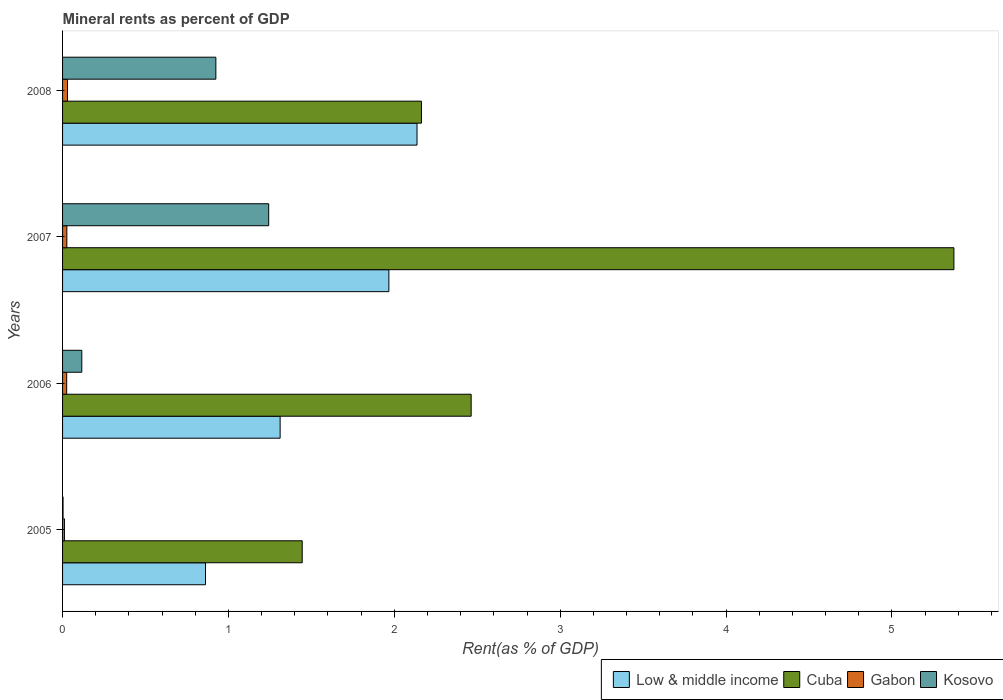How many groups of bars are there?
Make the answer very short. 4. How many bars are there on the 2nd tick from the top?
Your response must be concise. 4. How many bars are there on the 4th tick from the bottom?
Your answer should be very brief. 4. What is the label of the 4th group of bars from the top?
Ensure brevity in your answer.  2005. What is the mineral rent in Gabon in 2006?
Ensure brevity in your answer.  0.02. Across all years, what is the maximum mineral rent in Low & middle income?
Your response must be concise. 2.14. Across all years, what is the minimum mineral rent in Kosovo?
Your answer should be very brief. 0. What is the total mineral rent in Gabon in the graph?
Offer a terse response. 0.09. What is the difference between the mineral rent in Low & middle income in 2006 and that in 2008?
Give a very brief answer. -0.83. What is the difference between the mineral rent in Low & middle income in 2006 and the mineral rent in Cuba in 2008?
Your answer should be compact. -0.85. What is the average mineral rent in Kosovo per year?
Offer a terse response. 0.57. In the year 2006, what is the difference between the mineral rent in Low & middle income and mineral rent in Cuba?
Give a very brief answer. -1.15. What is the ratio of the mineral rent in Kosovo in 2006 to that in 2007?
Your answer should be very brief. 0.09. Is the mineral rent in Cuba in 2005 less than that in 2008?
Provide a succinct answer. Yes. What is the difference between the highest and the second highest mineral rent in Kosovo?
Your answer should be compact. 0.32. What is the difference between the highest and the lowest mineral rent in Kosovo?
Keep it short and to the point. 1.24. In how many years, is the mineral rent in Cuba greater than the average mineral rent in Cuba taken over all years?
Offer a terse response. 1. Is it the case that in every year, the sum of the mineral rent in Cuba and mineral rent in Low & middle income is greater than the sum of mineral rent in Gabon and mineral rent in Kosovo?
Make the answer very short. No. What does the 1st bar from the top in 2005 represents?
Your answer should be very brief. Kosovo. What does the 1st bar from the bottom in 2006 represents?
Provide a short and direct response. Low & middle income. Are all the bars in the graph horizontal?
Ensure brevity in your answer.  Yes. What is the difference between two consecutive major ticks on the X-axis?
Ensure brevity in your answer.  1. Are the values on the major ticks of X-axis written in scientific E-notation?
Give a very brief answer. No. Does the graph contain any zero values?
Keep it short and to the point. No. Does the graph contain grids?
Make the answer very short. No. Where does the legend appear in the graph?
Make the answer very short. Bottom right. How many legend labels are there?
Keep it short and to the point. 4. What is the title of the graph?
Your response must be concise. Mineral rents as percent of GDP. Does "Portugal" appear as one of the legend labels in the graph?
Provide a short and direct response. No. What is the label or title of the X-axis?
Ensure brevity in your answer.  Rent(as % of GDP). What is the Rent(as % of GDP) of Low & middle income in 2005?
Your answer should be very brief. 0.86. What is the Rent(as % of GDP) of Cuba in 2005?
Ensure brevity in your answer.  1.44. What is the Rent(as % of GDP) of Gabon in 2005?
Provide a succinct answer. 0.01. What is the Rent(as % of GDP) of Kosovo in 2005?
Make the answer very short. 0. What is the Rent(as % of GDP) of Low & middle income in 2006?
Make the answer very short. 1.31. What is the Rent(as % of GDP) in Cuba in 2006?
Keep it short and to the point. 2.46. What is the Rent(as % of GDP) in Gabon in 2006?
Provide a succinct answer. 0.02. What is the Rent(as % of GDP) of Kosovo in 2006?
Give a very brief answer. 0.12. What is the Rent(as % of GDP) in Low & middle income in 2007?
Offer a very short reply. 1.97. What is the Rent(as % of GDP) of Cuba in 2007?
Provide a short and direct response. 5.37. What is the Rent(as % of GDP) in Gabon in 2007?
Ensure brevity in your answer.  0.03. What is the Rent(as % of GDP) of Kosovo in 2007?
Offer a terse response. 1.24. What is the Rent(as % of GDP) in Low & middle income in 2008?
Offer a terse response. 2.14. What is the Rent(as % of GDP) in Cuba in 2008?
Ensure brevity in your answer.  2.16. What is the Rent(as % of GDP) in Gabon in 2008?
Ensure brevity in your answer.  0.03. What is the Rent(as % of GDP) of Kosovo in 2008?
Offer a terse response. 0.92. Across all years, what is the maximum Rent(as % of GDP) of Low & middle income?
Keep it short and to the point. 2.14. Across all years, what is the maximum Rent(as % of GDP) in Cuba?
Your answer should be compact. 5.37. Across all years, what is the maximum Rent(as % of GDP) of Gabon?
Offer a terse response. 0.03. Across all years, what is the maximum Rent(as % of GDP) of Kosovo?
Keep it short and to the point. 1.24. Across all years, what is the minimum Rent(as % of GDP) in Low & middle income?
Make the answer very short. 0.86. Across all years, what is the minimum Rent(as % of GDP) in Cuba?
Provide a succinct answer. 1.44. Across all years, what is the minimum Rent(as % of GDP) in Gabon?
Your answer should be compact. 0.01. Across all years, what is the minimum Rent(as % of GDP) of Kosovo?
Provide a succinct answer. 0. What is the total Rent(as % of GDP) of Low & middle income in the graph?
Offer a very short reply. 6.28. What is the total Rent(as % of GDP) in Cuba in the graph?
Provide a succinct answer. 11.44. What is the total Rent(as % of GDP) of Gabon in the graph?
Provide a succinct answer. 0.09. What is the total Rent(as % of GDP) of Kosovo in the graph?
Your response must be concise. 2.29. What is the difference between the Rent(as % of GDP) in Low & middle income in 2005 and that in 2006?
Offer a terse response. -0.45. What is the difference between the Rent(as % of GDP) in Cuba in 2005 and that in 2006?
Ensure brevity in your answer.  -1.02. What is the difference between the Rent(as % of GDP) of Gabon in 2005 and that in 2006?
Keep it short and to the point. -0.01. What is the difference between the Rent(as % of GDP) in Kosovo in 2005 and that in 2006?
Your answer should be compact. -0.11. What is the difference between the Rent(as % of GDP) of Low & middle income in 2005 and that in 2007?
Offer a very short reply. -1.11. What is the difference between the Rent(as % of GDP) in Cuba in 2005 and that in 2007?
Ensure brevity in your answer.  -3.93. What is the difference between the Rent(as % of GDP) in Gabon in 2005 and that in 2007?
Offer a very short reply. -0.01. What is the difference between the Rent(as % of GDP) of Kosovo in 2005 and that in 2007?
Ensure brevity in your answer.  -1.24. What is the difference between the Rent(as % of GDP) of Low & middle income in 2005 and that in 2008?
Your response must be concise. -1.28. What is the difference between the Rent(as % of GDP) of Cuba in 2005 and that in 2008?
Give a very brief answer. -0.72. What is the difference between the Rent(as % of GDP) of Gabon in 2005 and that in 2008?
Your answer should be compact. -0.02. What is the difference between the Rent(as % of GDP) of Kosovo in 2005 and that in 2008?
Provide a short and direct response. -0.92. What is the difference between the Rent(as % of GDP) of Low & middle income in 2006 and that in 2007?
Provide a short and direct response. -0.66. What is the difference between the Rent(as % of GDP) of Cuba in 2006 and that in 2007?
Provide a short and direct response. -2.91. What is the difference between the Rent(as % of GDP) of Gabon in 2006 and that in 2007?
Ensure brevity in your answer.  -0. What is the difference between the Rent(as % of GDP) of Kosovo in 2006 and that in 2007?
Offer a terse response. -1.13. What is the difference between the Rent(as % of GDP) of Low & middle income in 2006 and that in 2008?
Provide a succinct answer. -0.83. What is the difference between the Rent(as % of GDP) in Cuba in 2006 and that in 2008?
Offer a terse response. 0.3. What is the difference between the Rent(as % of GDP) in Gabon in 2006 and that in 2008?
Your response must be concise. -0.01. What is the difference between the Rent(as % of GDP) in Kosovo in 2006 and that in 2008?
Ensure brevity in your answer.  -0.81. What is the difference between the Rent(as % of GDP) of Low & middle income in 2007 and that in 2008?
Offer a terse response. -0.17. What is the difference between the Rent(as % of GDP) of Cuba in 2007 and that in 2008?
Ensure brevity in your answer.  3.21. What is the difference between the Rent(as % of GDP) of Gabon in 2007 and that in 2008?
Offer a very short reply. -0. What is the difference between the Rent(as % of GDP) of Kosovo in 2007 and that in 2008?
Your answer should be very brief. 0.32. What is the difference between the Rent(as % of GDP) in Low & middle income in 2005 and the Rent(as % of GDP) in Cuba in 2006?
Keep it short and to the point. -1.6. What is the difference between the Rent(as % of GDP) of Low & middle income in 2005 and the Rent(as % of GDP) of Gabon in 2006?
Ensure brevity in your answer.  0.84. What is the difference between the Rent(as % of GDP) in Low & middle income in 2005 and the Rent(as % of GDP) in Kosovo in 2006?
Provide a short and direct response. 0.75. What is the difference between the Rent(as % of GDP) of Cuba in 2005 and the Rent(as % of GDP) of Gabon in 2006?
Keep it short and to the point. 1.42. What is the difference between the Rent(as % of GDP) of Cuba in 2005 and the Rent(as % of GDP) of Kosovo in 2006?
Give a very brief answer. 1.33. What is the difference between the Rent(as % of GDP) of Gabon in 2005 and the Rent(as % of GDP) of Kosovo in 2006?
Give a very brief answer. -0.1. What is the difference between the Rent(as % of GDP) in Low & middle income in 2005 and the Rent(as % of GDP) in Cuba in 2007?
Offer a very short reply. -4.51. What is the difference between the Rent(as % of GDP) of Low & middle income in 2005 and the Rent(as % of GDP) of Gabon in 2007?
Ensure brevity in your answer.  0.84. What is the difference between the Rent(as % of GDP) in Low & middle income in 2005 and the Rent(as % of GDP) in Kosovo in 2007?
Give a very brief answer. -0.38. What is the difference between the Rent(as % of GDP) of Cuba in 2005 and the Rent(as % of GDP) of Gabon in 2007?
Provide a short and direct response. 1.42. What is the difference between the Rent(as % of GDP) in Cuba in 2005 and the Rent(as % of GDP) in Kosovo in 2007?
Provide a succinct answer. 0.2. What is the difference between the Rent(as % of GDP) in Gabon in 2005 and the Rent(as % of GDP) in Kosovo in 2007?
Keep it short and to the point. -1.23. What is the difference between the Rent(as % of GDP) of Low & middle income in 2005 and the Rent(as % of GDP) of Cuba in 2008?
Keep it short and to the point. -1.3. What is the difference between the Rent(as % of GDP) in Low & middle income in 2005 and the Rent(as % of GDP) in Gabon in 2008?
Offer a terse response. 0.83. What is the difference between the Rent(as % of GDP) in Low & middle income in 2005 and the Rent(as % of GDP) in Kosovo in 2008?
Your answer should be very brief. -0.06. What is the difference between the Rent(as % of GDP) in Cuba in 2005 and the Rent(as % of GDP) in Gabon in 2008?
Your response must be concise. 1.41. What is the difference between the Rent(as % of GDP) of Cuba in 2005 and the Rent(as % of GDP) of Kosovo in 2008?
Ensure brevity in your answer.  0.52. What is the difference between the Rent(as % of GDP) of Gabon in 2005 and the Rent(as % of GDP) of Kosovo in 2008?
Offer a very short reply. -0.91. What is the difference between the Rent(as % of GDP) in Low & middle income in 2006 and the Rent(as % of GDP) in Cuba in 2007?
Offer a terse response. -4.06. What is the difference between the Rent(as % of GDP) of Low & middle income in 2006 and the Rent(as % of GDP) of Kosovo in 2007?
Your answer should be very brief. 0.07. What is the difference between the Rent(as % of GDP) of Cuba in 2006 and the Rent(as % of GDP) of Gabon in 2007?
Ensure brevity in your answer.  2.44. What is the difference between the Rent(as % of GDP) of Cuba in 2006 and the Rent(as % of GDP) of Kosovo in 2007?
Keep it short and to the point. 1.22. What is the difference between the Rent(as % of GDP) of Gabon in 2006 and the Rent(as % of GDP) of Kosovo in 2007?
Your answer should be compact. -1.22. What is the difference between the Rent(as % of GDP) of Low & middle income in 2006 and the Rent(as % of GDP) of Cuba in 2008?
Give a very brief answer. -0.85. What is the difference between the Rent(as % of GDP) of Low & middle income in 2006 and the Rent(as % of GDP) of Gabon in 2008?
Keep it short and to the point. 1.28. What is the difference between the Rent(as % of GDP) of Low & middle income in 2006 and the Rent(as % of GDP) of Kosovo in 2008?
Make the answer very short. 0.39. What is the difference between the Rent(as % of GDP) of Cuba in 2006 and the Rent(as % of GDP) of Gabon in 2008?
Make the answer very short. 2.43. What is the difference between the Rent(as % of GDP) in Cuba in 2006 and the Rent(as % of GDP) in Kosovo in 2008?
Give a very brief answer. 1.54. What is the difference between the Rent(as % of GDP) in Gabon in 2006 and the Rent(as % of GDP) in Kosovo in 2008?
Offer a terse response. -0.9. What is the difference between the Rent(as % of GDP) of Low & middle income in 2007 and the Rent(as % of GDP) of Cuba in 2008?
Provide a short and direct response. -0.2. What is the difference between the Rent(as % of GDP) in Low & middle income in 2007 and the Rent(as % of GDP) in Gabon in 2008?
Your response must be concise. 1.94. What is the difference between the Rent(as % of GDP) of Low & middle income in 2007 and the Rent(as % of GDP) of Kosovo in 2008?
Offer a terse response. 1.04. What is the difference between the Rent(as % of GDP) in Cuba in 2007 and the Rent(as % of GDP) in Gabon in 2008?
Offer a terse response. 5.34. What is the difference between the Rent(as % of GDP) of Cuba in 2007 and the Rent(as % of GDP) of Kosovo in 2008?
Your answer should be very brief. 4.45. What is the difference between the Rent(as % of GDP) of Gabon in 2007 and the Rent(as % of GDP) of Kosovo in 2008?
Provide a short and direct response. -0.9. What is the average Rent(as % of GDP) of Low & middle income per year?
Provide a short and direct response. 1.57. What is the average Rent(as % of GDP) in Cuba per year?
Your answer should be very brief. 2.86. What is the average Rent(as % of GDP) of Gabon per year?
Offer a terse response. 0.02. What is the average Rent(as % of GDP) of Kosovo per year?
Ensure brevity in your answer.  0.57. In the year 2005, what is the difference between the Rent(as % of GDP) of Low & middle income and Rent(as % of GDP) of Cuba?
Ensure brevity in your answer.  -0.58. In the year 2005, what is the difference between the Rent(as % of GDP) of Low & middle income and Rent(as % of GDP) of Gabon?
Make the answer very short. 0.85. In the year 2005, what is the difference between the Rent(as % of GDP) in Low & middle income and Rent(as % of GDP) in Kosovo?
Ensure brevity in your answer.  0.86. In the year 2005, what is the difference between the Rent(as % of GDP) in Cuba and Rent(as % of GDP) in Gabon?
Provide a succinct answer. 1.43. In the year 2005, what is the difference between the Rent(as % of GDP) of Cuba and Rent(as % of GDP) of Kosovo?
Make the answer very short. 1.44. In the year 2005, what is the difference between the Rent(as % of GDP) in Gabon and Rent(as % of GDP) in Kosovo?
Offer a terse response. 0.01. In the year 2006, what is the difference between the Rent(as % of GDP) in Low & middle income and Rent(as % of GDP) in Cuba?
Offer a very short reply. -1.15. In the year 2006, what is the difference between the Rent(as % of GDP) in Low & middle income and Rent(as % of GDP) in Gabon?
Provide a succinct answer. 1.29. In the year 2006, what is the difference between the Rent(as % of GDP) in Low & middle income and Rent(as % of GDP) in Kosovo?
Provide a succinct answer. 1.2. In the year 2006, what is the difference between the Rent(as % of GDP) of Cuba and Rent(as % of GDP) of Gabon?
Provide a succinct answer. 2.44. In the year 2006, what is the difference between the Rent(as % of GDP) of Cuba and Rent(as % of GDP) of Kosovo?
Your response must be concise. 2.35. In the year 2006, what is the difference between the Rent(as % of GDP) in Gabon and Rent(as % of GDP) in Kosovo?
Keep it short and to the point. -0.09. In the year 2007, what is the difference between the Rent(as % of GDP) in Low & middle income and Rent(as % of GDP) in Cuba?
Ensure brevity in your answer.  -3.41. In the year 2007, what is the difference between the Rent(as % of GDP) in Low & middle income and Rent(as % of GDP) in Gabon?
Ensure brevity in your answer.  1.94. In the year 2007, what is the difference between the Rent(as % of GDP) in Low & middle income and Rent(as % of GDP) in Kosovo?
Provide a succinct answer. 0.72. In the year 2007, what is the difference between the Rent(as % of GDP) in Cuba and Rent(as % of GDP) in Gabon?
Keep it short and to the point. 5.35. In the year 2007, what is the difference between the Rent(as % of GDP) of Cuba and Rent(as % of GDP) of Kosovo?
Ensure brevity in your answer.  4.13. In the year 2007, what is the difference between the Rent(as % of GDP) in Gabon and Rent(as % of GDP) in Kosovo?
Your response must be concise. -1.22. In the year 2008, what is the difference between the Rent(as % of GDP) of Low & middle income and Rent(as % of GDP) of Cuba?
Make the answer very short. -0.03. In the year 2008, what is the difference between the Rent(as % of GDP) of Low & middle income and Rent(as % of GDP) of Gabon?
Keep it short and to the point. 2.11. In the year 2008, what is the difference between the Rent(as % of GDP) of Low & middle income and Rent(as % of GDP) of Kosovo?
Offer a very short reply. 1.21. In the year 2008, what is the difference between the Rent(as % of GDP) in Cuba and Rent(as % of GDP) in Gabon?
Ensure brevity in your answer.  2.13. In the year 2008, what is the difference between the Rent(as % of GDP) in Cuba and Rent(as % of GDP) in Kosovo?
Your answer should be compact. 1.24. In the year 2008, what is the difference between the Rent(as % of GDP) in Gabon and Rent(as % of GDP) in Kosovo?
Ensure brevity in your answer.  -0.89. What is the ratio of the Rent(as % of GDP) of Low & middle income in 2005 to that in 2006?
Provide a succinct answer. 0.66. What is the ratio of the Rent(as % of GDP) of Cuba in 2005 to that in 2006?
Offer a very short reply. 0.59. What is the ratio of the Rent(as % of GDP) in Gabon in 2005 to that in 2006?
Make the answer very short. 0.45. What is the ratio of the Rent(as % of GDP) of Kosovo in 2005 to that in 2006?
Ensure brevity in your answer.  0.03. What is the ratio of the Rent(as % of GDP) in Low & middle income in 2005 to that in 2007?
Your answer should be compact. 0.44. What is the ratio of the Rent(as % of GDP) in Cuba in 2005 to that in 2007?
Make the answer very short. 0.27. What is the ratio of the Rent(as % of GDP) of Gabon in 2005 to that in 2007?
Provide a short and direct response. 0.44. What is the ratio of the Rent(as % of GDP) of Kosovo in 2005 to that in 2007?
Offer a very short reply. 0. What is the ratio of the Rent(as % of GDP) of Low & middle income in 2005 to that in 2008?
Provide a short and direct response. 0.4. What is the ratio of the Rent(as % of GDP) of Cuba in 2005 to that in 2008?
Your answer should be compact. 0.67. What is the ratio of the Rent(as % of GDP) in Gabon in 2005 to that in 2008?
Keep it short and to the point. 0.38. What is the ratio of the Rent(as % of GDP) of Kosovo in 2005 to that in 2008?
Make the answer very short. 0. What is the ratio of the Rent(as % of GDP) of Cuba in 2006 to that in 2007?
Offer a very short reply. 0.46. What is the ratio of the Rent(as % of GDP) in Gabon in 2006 to that in 2007?
Keep it short and to the point. 0.96. What is the ratio of the Rent(as % of GDP) in Kosovo in 2006 to that in 2007?
Provide a short and direct response. 0.09. What is the ratio of the Rent(as % of GDP) in Low & middle income in 2006 to that in 2008?
Make the answer very short. 0.61. What is the ratio of the Rent(as % of GDP) in Cuba in 2006 to that in 2008?
Offer a terse response. 1.14. What is the ratio of the Rent(as % of GDP) of Gabon in 2006 to that in 2008?
Offer a very short reply. 0.83. What is the ratio of the Rent(as % of GDP) of Kosovo in 2006 to that in 2008?
Keep it short and to the point. 0.13. What is the ratio of the Rent(as % of GDP) in Low & middle income in 2007 to that in 2008?
Provide a short and direct response. 0.92. What is the ratio of the Rent(as % of GDP) of Cuba in 2007 to that in 2008?
Ensure brevity in your answer.  2.48. What is the ratio of the Rent(as % of GDP) of Gabon in 2007 to that in 2008?
Keep it short and to the point. 0.87. What is the ratio of the Rent(as % of GDP) in Kosovo in 2007 to that in 2008?
Ensure brevity in your answer.  1.34. What is the difference between the highest and the second highest Rent(as % of GDP) in Low & middle income?
Offer a very short reply. 0.17. What is the difference between the highest and the second highest Rent(as % of GDP) in Cuba?
Make the answer very short. 2.91. What is the difference between the highest and the second highest Rent(as % of GDP) in Gabon?
Offer a very short reply. 0. What is the difference between the highest and the second highest Rent(as % of GDP) of Kosovo?
Provide a short and direct response. 0.32. What is the difference between the highest and the lowest Rent(as % of GDP) in Low & middle income?
Give a very brief answer. 1.28. What is the difference between the highest and the lowest Rent(as % of GDP) in Cuba?
Provide a short and direct response. 3.93. What is the difference between the highest and the lowest Rent(as % of GDP) in Gabon?
Keep it short and to the point. 0.02. What is the difference between the highest and the lowest Rent(as % of GDP) in Kosovo?
Offer a very short reply. 1.24. 